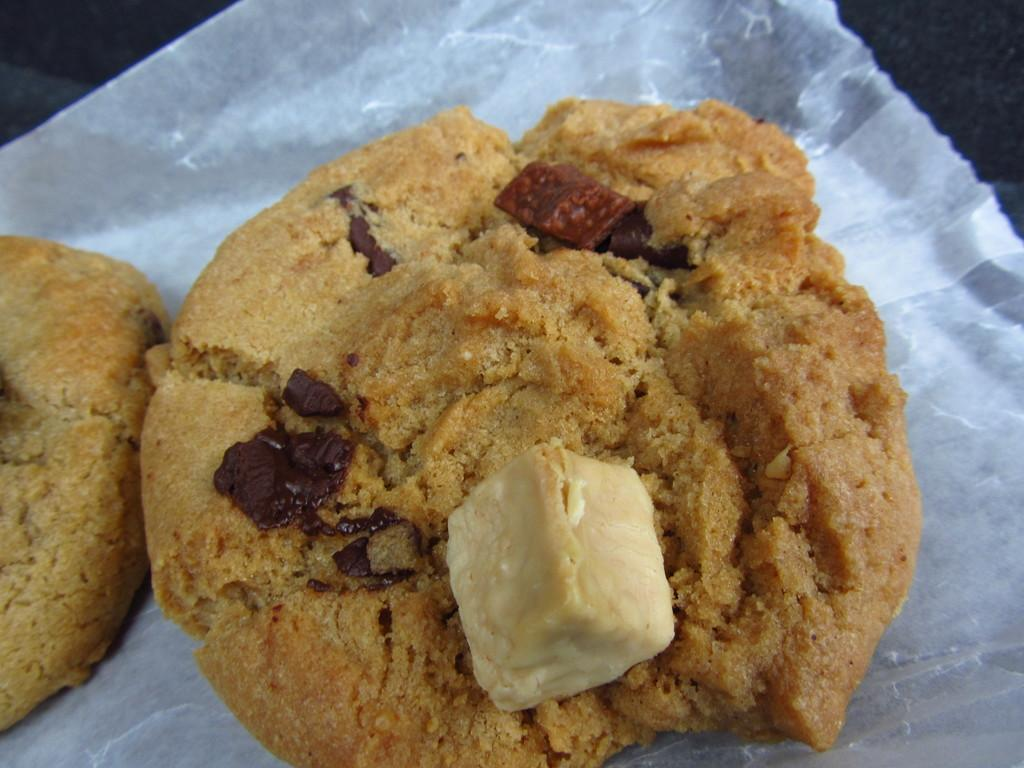What colors are used for the food in the image? The food in the image is in brown and cream colors. What is the food placed on? The food is placed on white paper. What color is the background of the image? The background of the image is black. What type of guide is present in the image? There is no guide present in the image; it features food in brown and cream colors placed on white paper with a black background. 